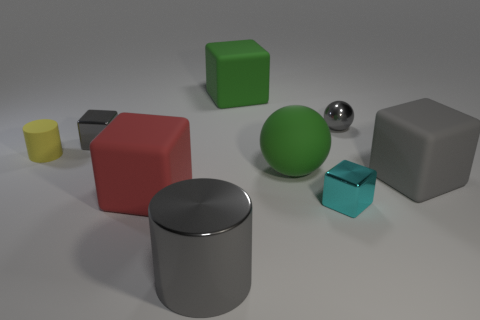Subtract 2 cubes. How many cubes are left? 3 Subtract all green blocks. How many blocks are left? 4 Subtract all tiny gray blocks. How many blocks are left? 4 Subtract all brown cubes. Subtract all purple cylinders. How many cubes are left? 5 Add 1 red cubes. How many objects exist? 10 Subtract all cylinders. How many objects are left? 7 Subtract all big gray blocks. Subtract all cyan metallic blocks. How many objects are left? 7 Add 5 large green matte balls. How many large green matte balls are left? 6 Add 6 blue shiny cylinders. How many blue shiny cylinders exist? 6 Subtract 0 brown balls. How many objects are left? 9 